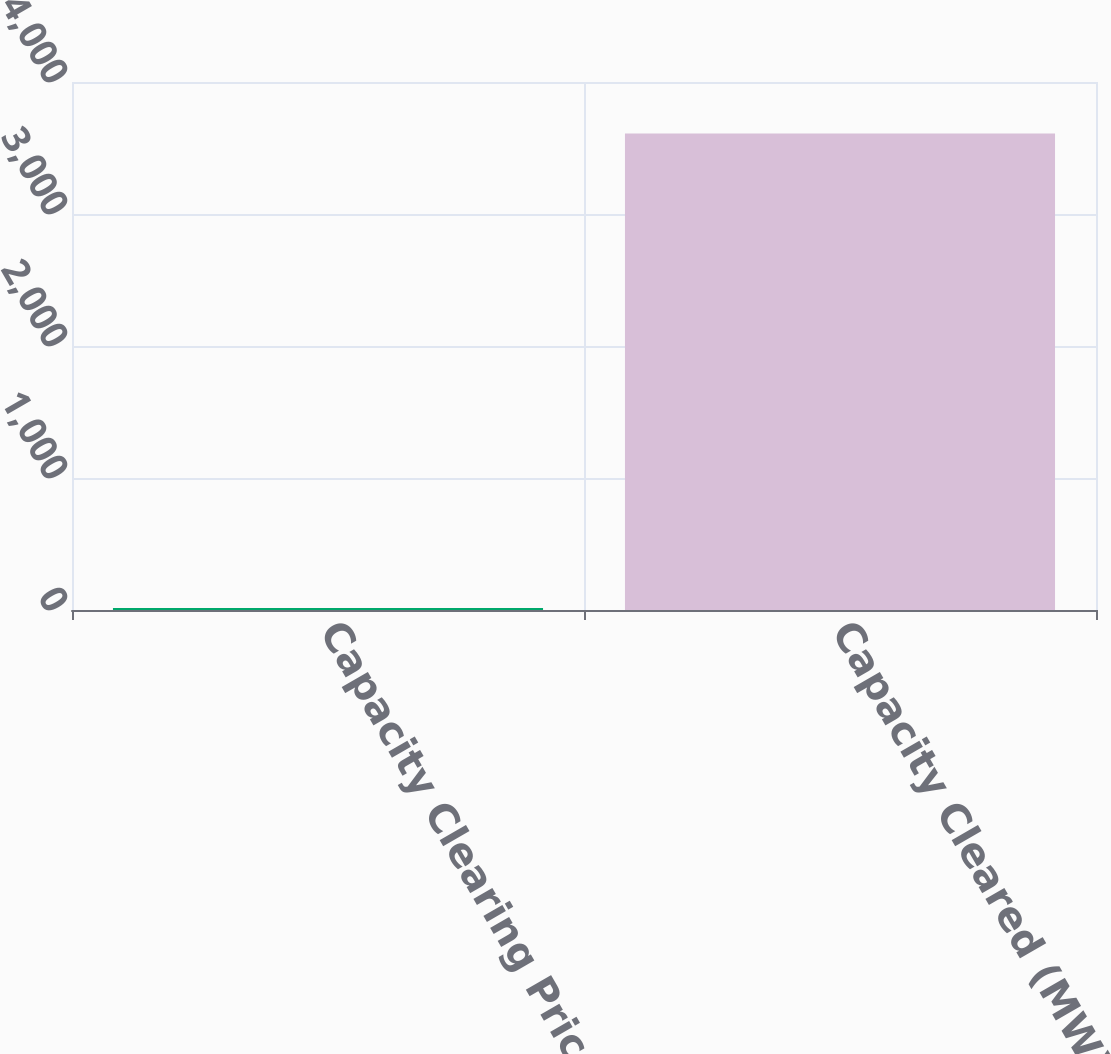Convert chart to OTSL. <chart><loc_0><loc_0><loc_500><loc_500><bar_chart><fcel>Capacity Clearing Price<fcel>Capacity Cleared (MW)<nl><fcel>16<fcel>3609<nl></chart> 